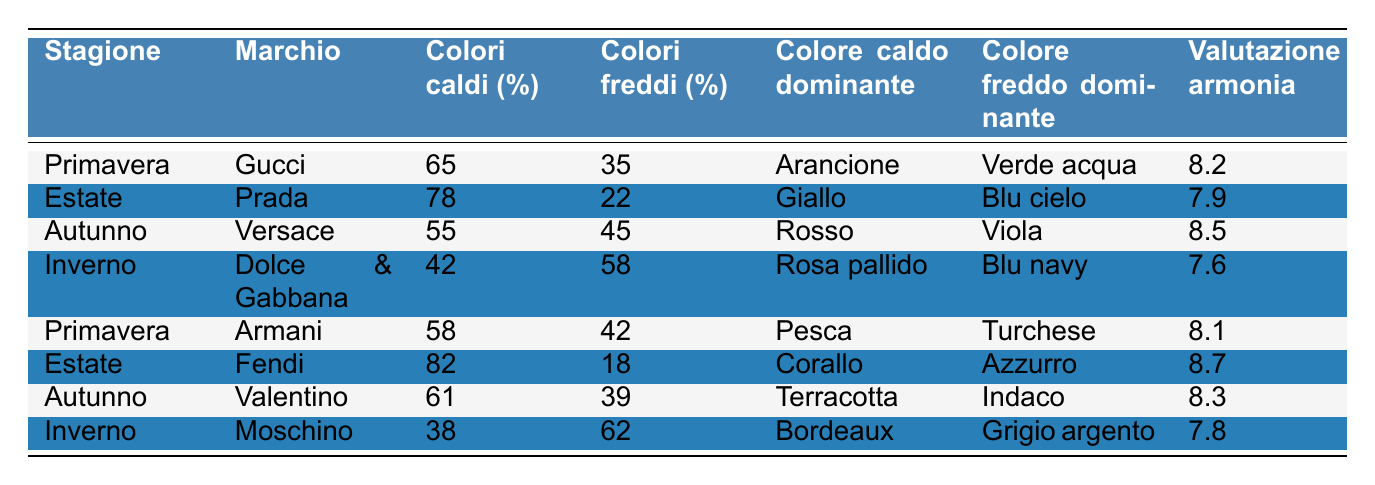Qual è la percentuale di colori caldi utilizzati da Fendi in estate? Nella riga corrispondente a Fendi, la percentuale di colori caldi è indicata come 82%.
Answer: 82% Qual è il colore caldo dominante per Gucci nella stagione primavera? Dalla riga di Gucci, il colore caldo dominante è specificato come Arancione.
Answer: Arancione Ci sono più percentuali di colori caldi o freddi in totale per il marchio Dolce & Gabbana? Per Dolce & Gabbana, la percentuale dei colori caldi è 42% e quella dei colori freddi è 58%. Poiché 58 è maggiore di 42, ci sono più colori freddi.
Answer: Colori freddi Qual è la percentuale media di colori caldi utilizzati nelle pubblicità di moda in estate? Sommiamo le percentuali di colori caldi per Prada e Fendi, cioè 78% + 82% = 160%. Dividiamo poi per 2 per ottenere la media: 160% / 2 = 80%.
Answer: 80% Chi utilizza la percentuale più alta di colori caldi nella primavera? Nella primavera, Gucci ha 65% e Armani ha 58%. Poiché 65% è maggiore di 58%, Gucci utilizza la percentuale più alta di colori caldi.
Answer: Gucci Quale marchio ha il punteggio di armonia dei colori più alto tra quelli che usano colori freddi? Uniamo le righe di Dolce & Gabbana (7.6), Moschino (7.8) e Fendi (8.7) per quelli che usano colori freddi. Il punteggio più alto è 8.7 di Fendi.
Answer: Fendi Qual è la differenza tra le percentuali di colori caldi e freddi nel marchio Valentino? Valentino ha 61% di colori caldi e 39% di colori freddi. Sottraendo i colori freddi dai colori caldi, 61% - 39% = 22%.
Answer: 22% Quale stagione ha il punteggio di armonia dei colori più basso tra tutte le marche? Controllando la colonna della valutazione di armonia, vediamo che Dolce & Gabbana ha il valore 7.6, che è il più basso rispetto agli altri.
Answer: Dolce & Gabbana Nella stagione dell'autunno, quali sono i colori dominanti e che percentuale di colori caldi è prevalente? Nel settore dell'autunno, Versace usa 55% di colori caldi e 45% di colori freddi con Rosso come colore caldo dominante e Viola come colore freddo dominante. Qui, i colori caldi sono prevalenti.
Answer: 55% di colori caldi 